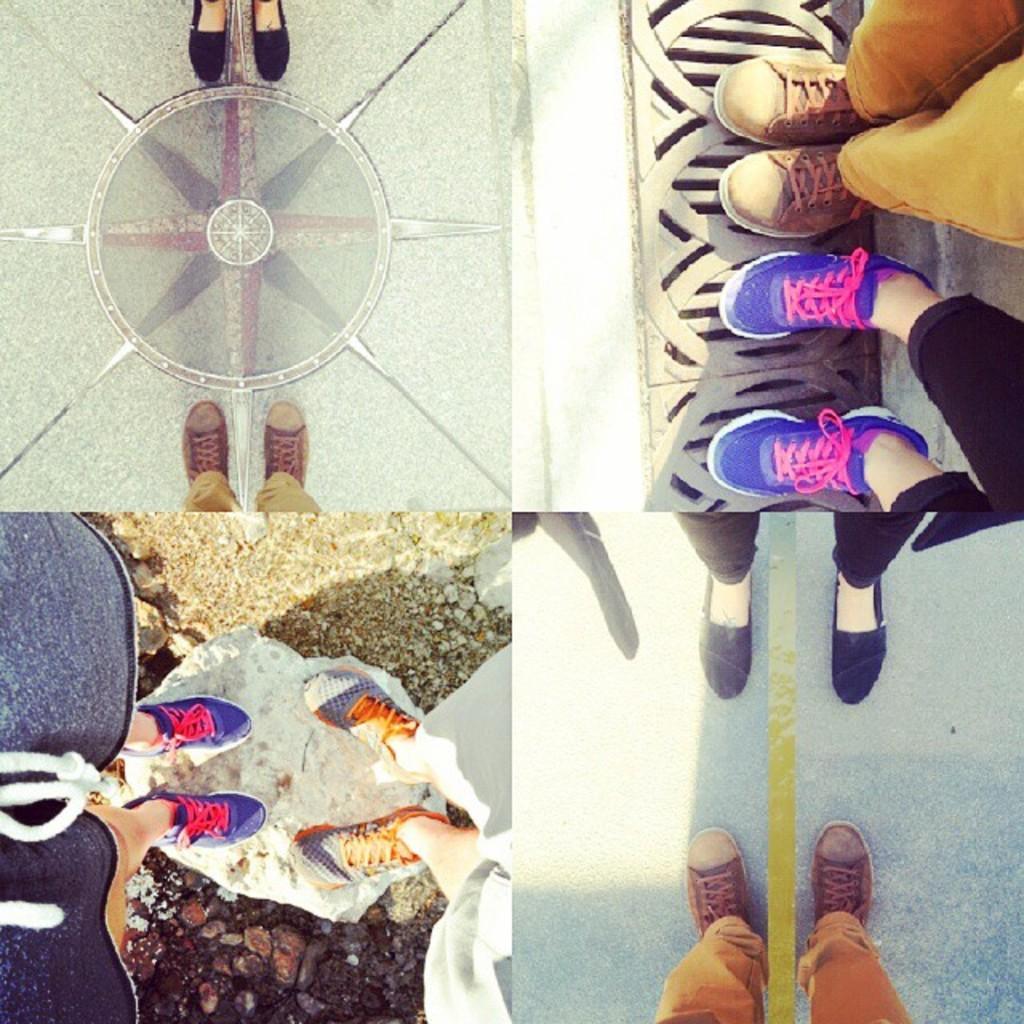Can you describe this image briefly? This is a collage image, we can see there are people legs. 